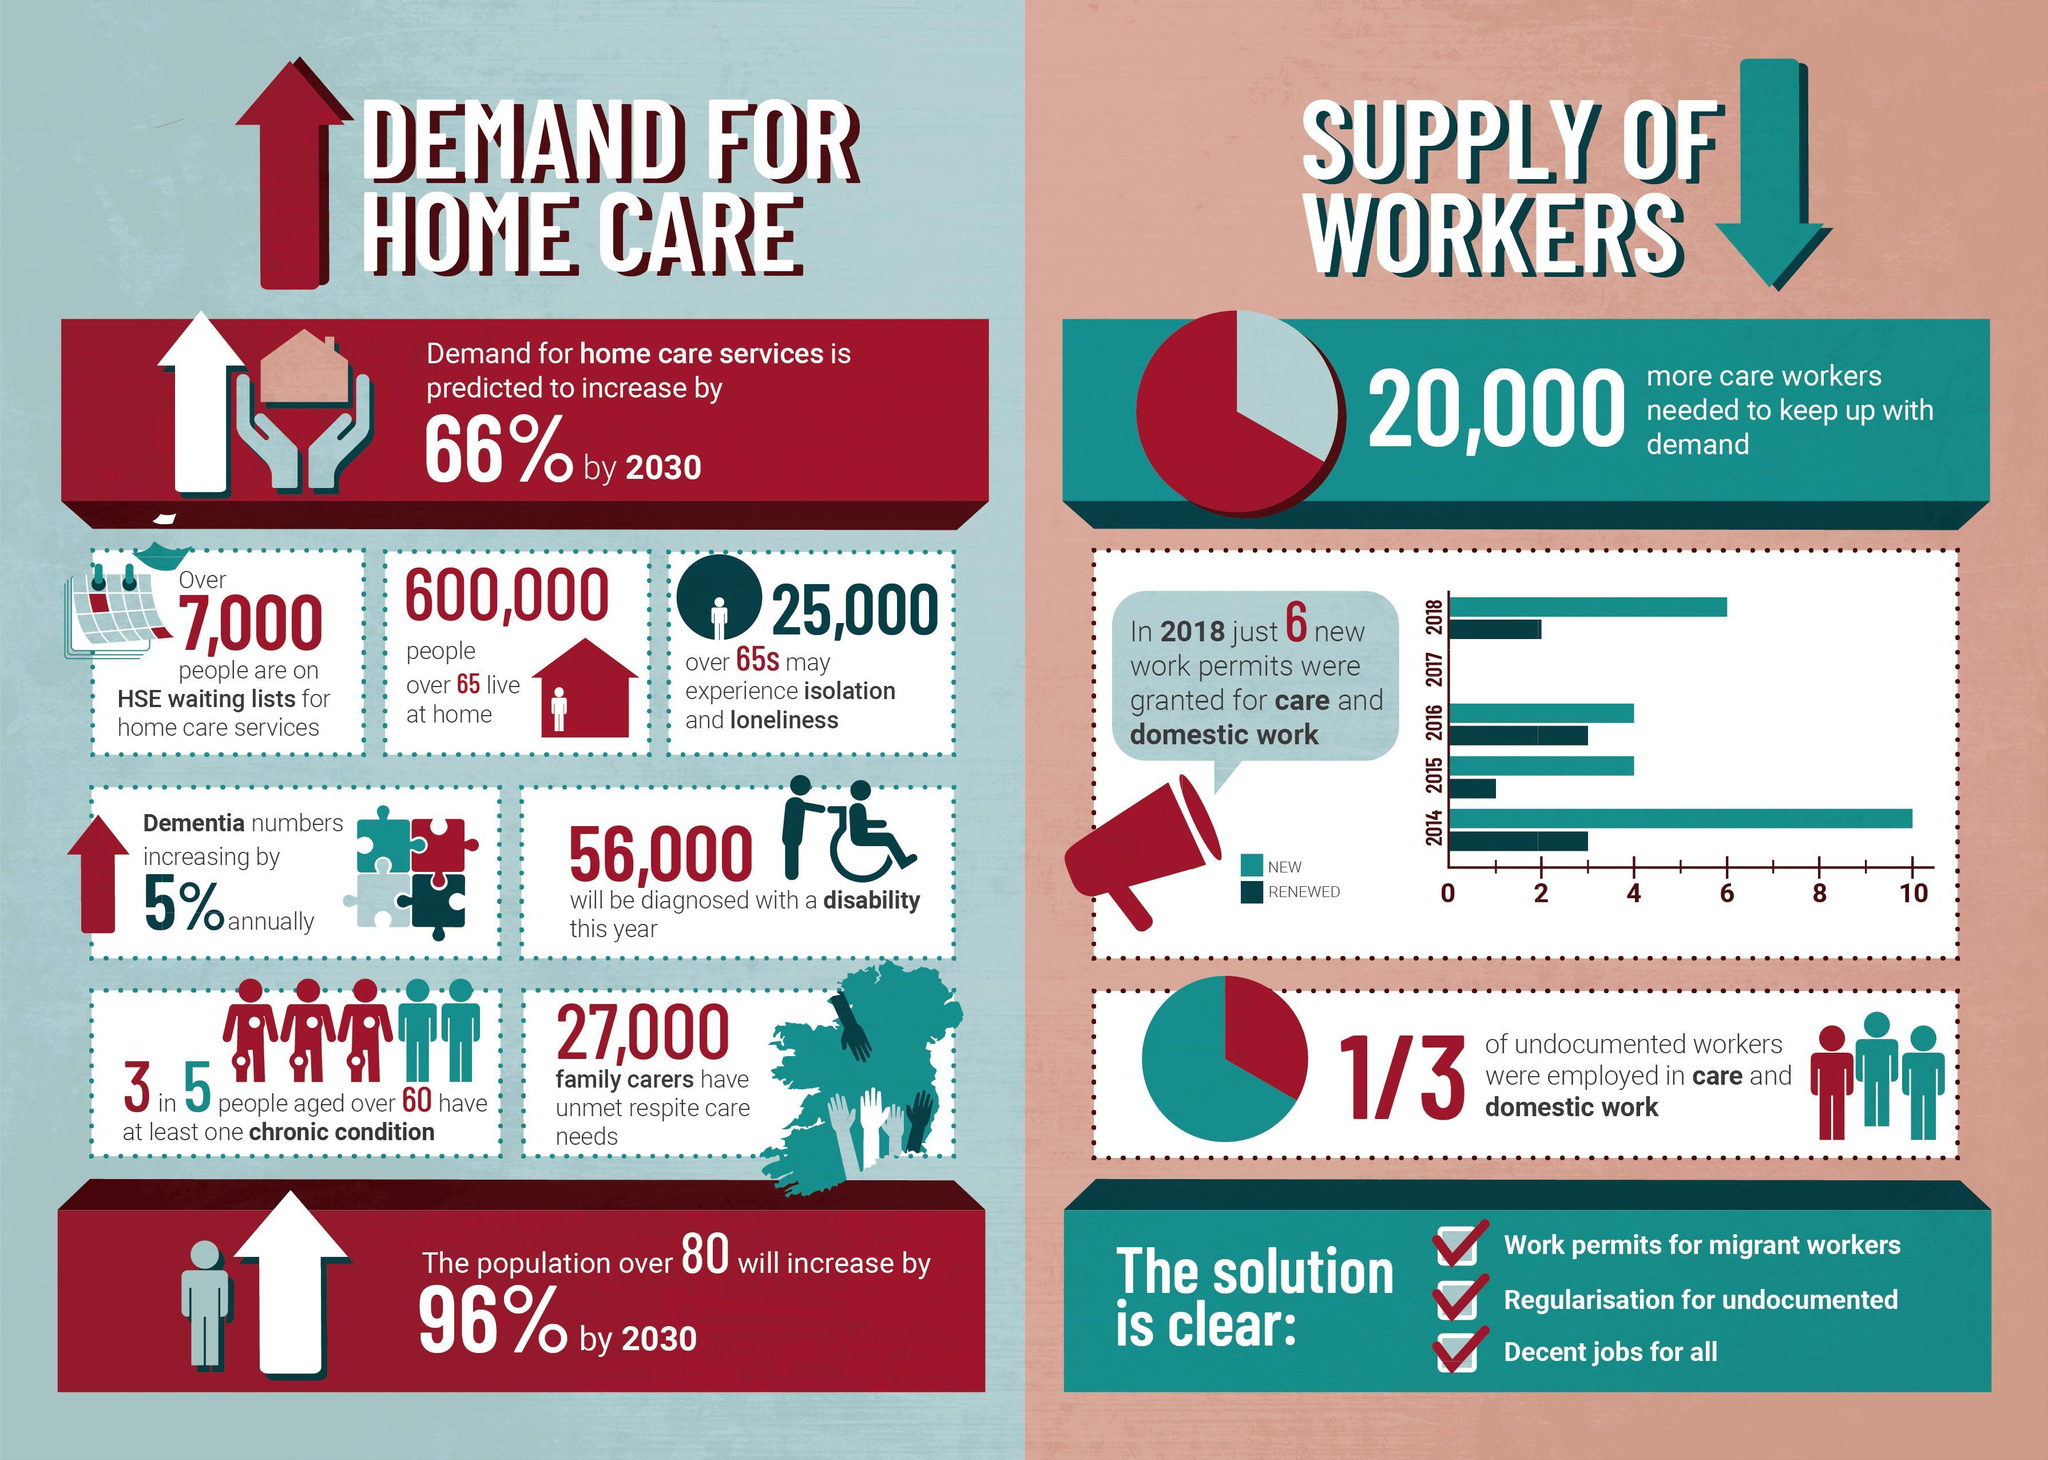How many work permits were renewed in the year 2016?
Answer the question with a short phrase. 3 How many new work permits was allowed in the year 2016? 4 How many new work permits was allowed in the year 2014? 10 How many work permits were renewed in the year 2014? 3 What is the inverse of the no of home care persons required in 2030? 34 How many work permits were renewed in the year 2015? 1 How many work permits were renewed in the year 2018? 2 How many new work permits was allowed in the year 2015? 4 